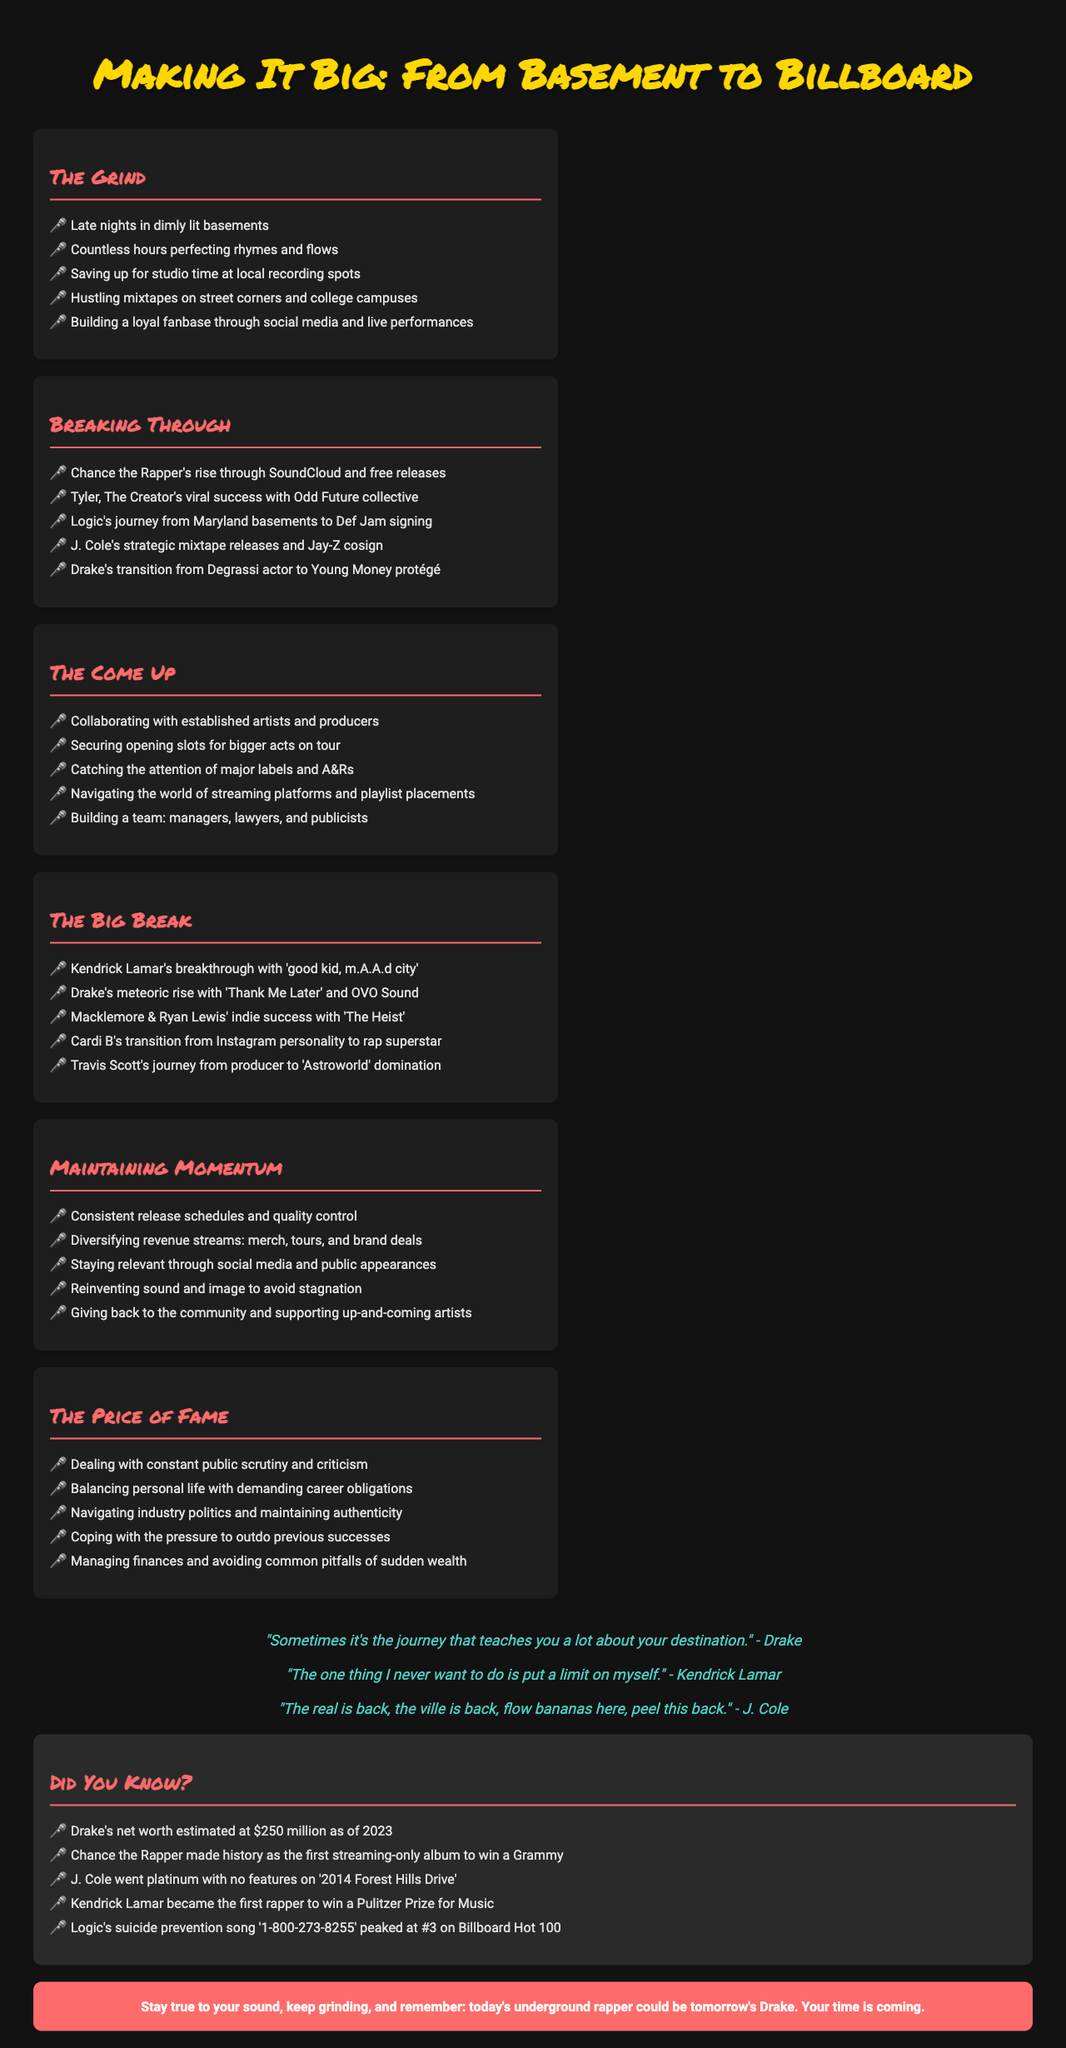What is the title of the brochure? The title of the brochure appears prominently at the top of the document.
Answer: Making It Big: From Basement to Billboard Who is mentioned alongside Chance the Rapper in the "Breaking Through" section? The "Breaking Through" section highlights various artists, including Drake.
Answer: Drake What is one way successful indie rappers maintain momentum? The document outlines multiple strategies for maintaining career momentum.
Answer: Consistent release schedules What year did J. Cole's album go platinum? The document includes specific achievements of different artists, including J. Cole.
Answer: 2014 Which artist won a Pulitzer Prize for Music? The sidebar facts reveal notable achievements of various artists, including Kendrick Lamar.
Answer: Kendrick Lamar What does the call to action suggest to underground rappers? The call to action provides encouragement and guidance for aspiring artists.
Answer: Stay true to your sound How many hours do artists typically spend perfecting their craft? The document estimates the time artists spend honing their skills.
Answer: Countless hours What does Drake state about the journey? A quote from Drake reflects his perspective on the importance of the journey.
Answer: Sometimes it's the journey that teaches you a lot about your destination What can help an artist catch the attention of major labels? The "Come Up" section lists strategies that artists use to gain visibility.
Answer: Collaborating with established artists 